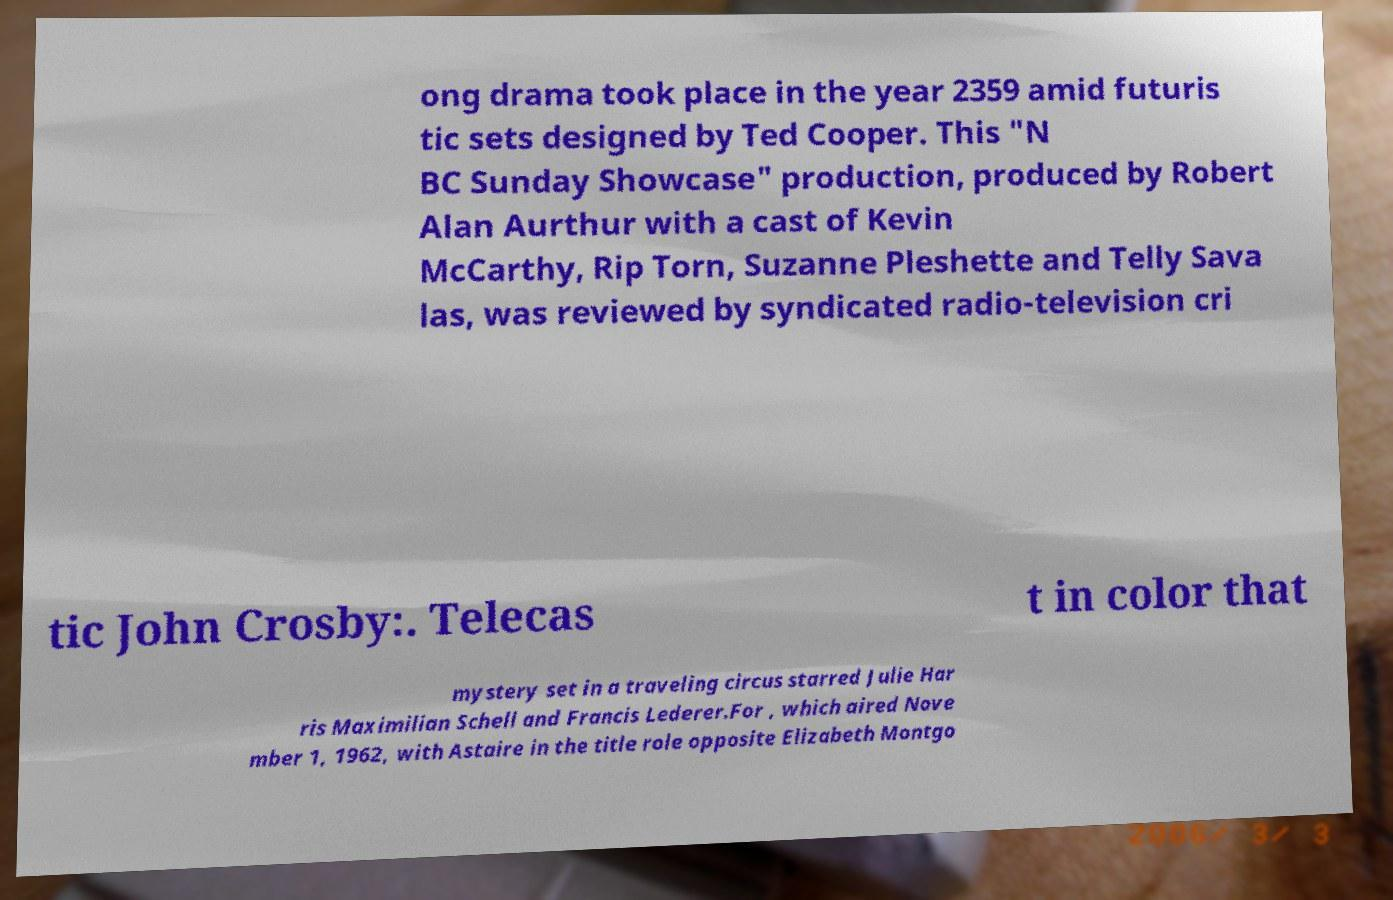I need the written content from this picture converted into text. Can you do that? ong drama took place in the year 2359 amid futuris tic sets designed by Ted Cooper. This "N BC Sunday Showcase" production, produced by Robert Alan Aurthur with a cast of Kevin McCarthy, Rip Torn, Suzanne Pleshette and Telly Sava las, was reviewed by syndicated radio-television cri tic John Crosby:. Telecas t in color that mystery set in a traveling circus starred Julie Har ris Maximilian Schell and Francis Lederer.For , which aired Nove mber 1, 1962, with Astaire in the title role opposite Elizabeth Montgo 